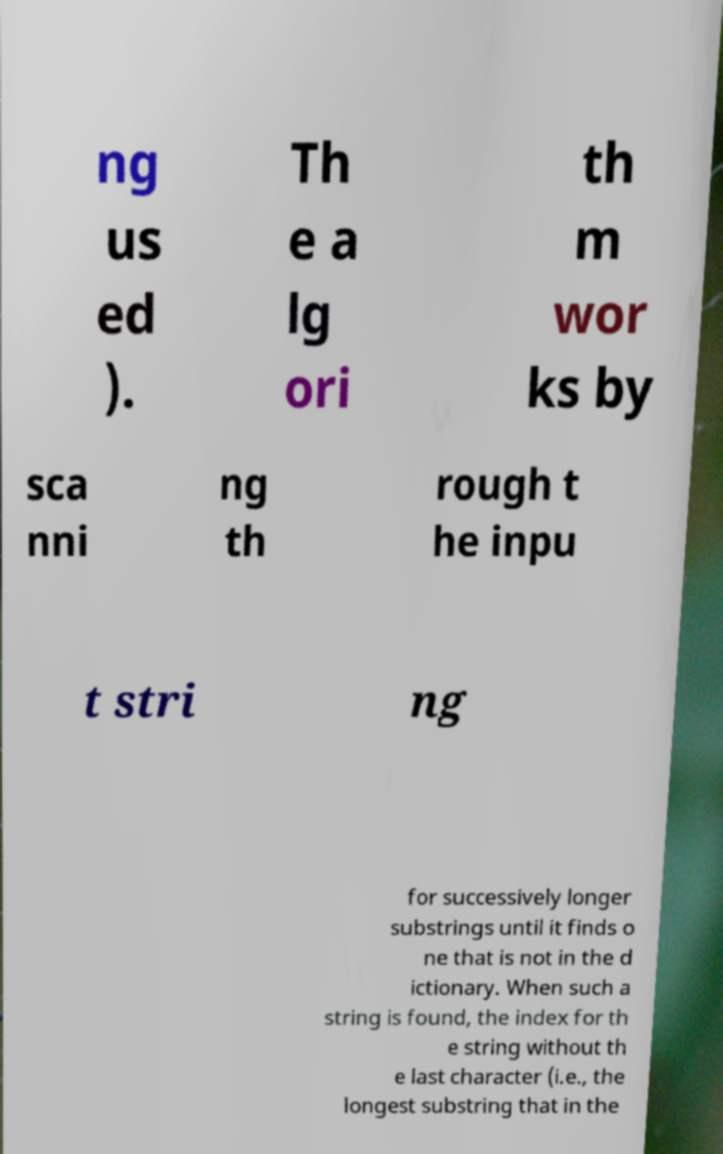Please read and relay the text visible in this image. What does it say? ng us ed ). Th e a lg ori th m wor ks by sca nni ng th rough t he inpu t stri ng for successively longer substrings until it finds o ne that is not in the d ictionary. When such a string is found, the index for th e string without th e last character (i.e., the longest substring that in the 